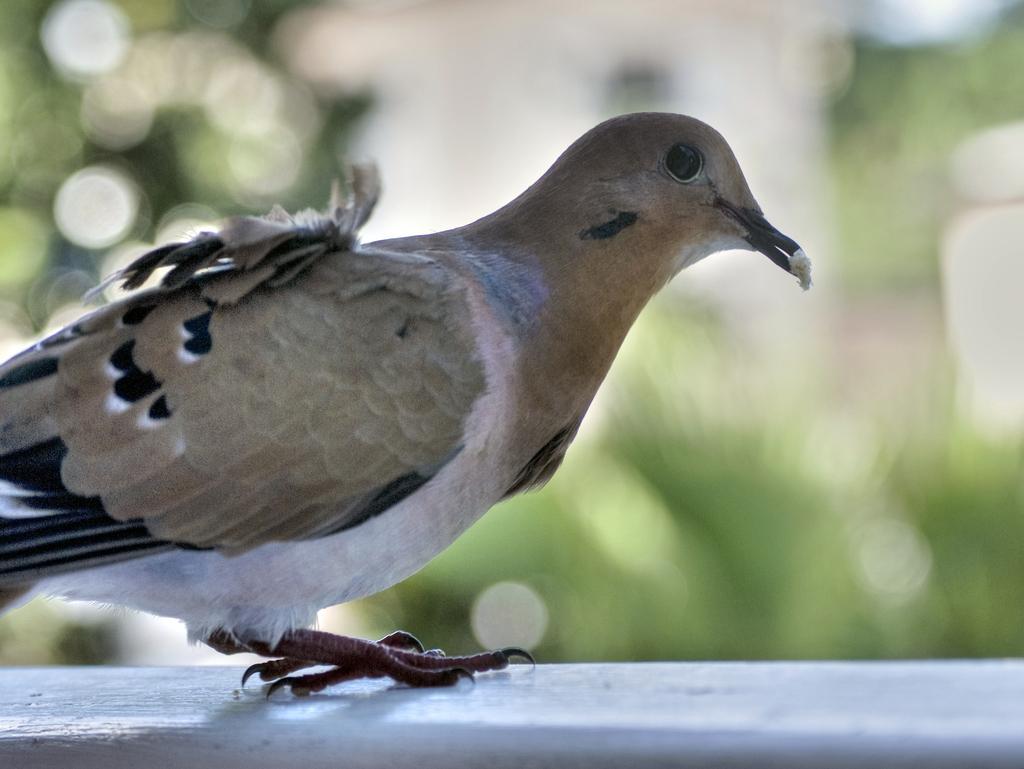In one or two sentences, can you explain what this image depicts? In this image we can see a bird on the surface which looks like a wall, and the background is blurred. 